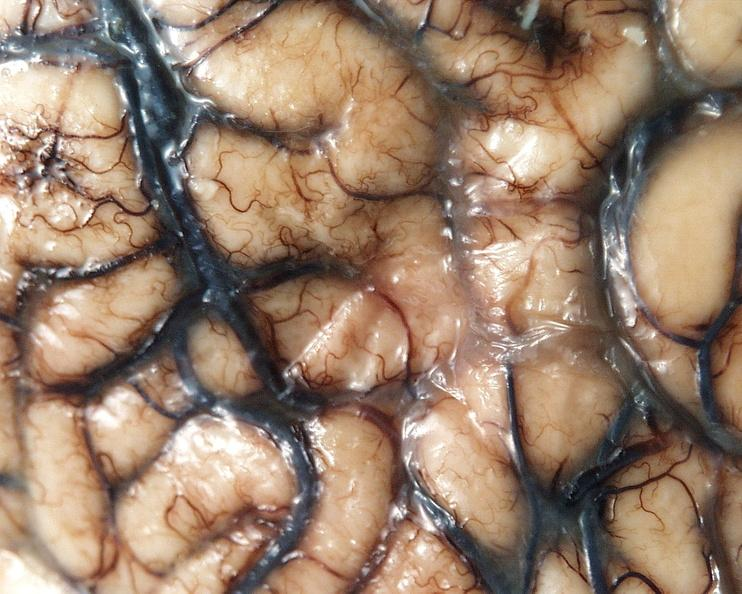what does this image show?
Answer the question using a single word or phrase. Brain 